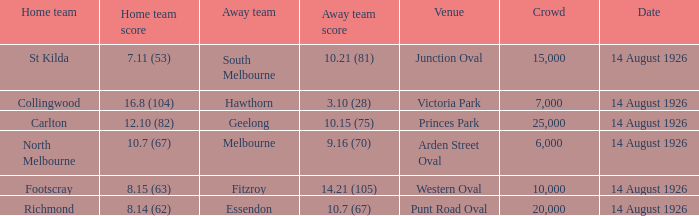What was the size of the largest crowd that Essendon played in front of as the away team? 20000.0. Can you give me this table as a dict? {'header': ['Home team', 'Home team score', 'Away team', 'Away team score', 'Venue', 'Crowd', 'Date'], 'rows': [['St Kilda', '7.11 (53)', 'South Melbourne', '10.21 (81)', 'Junction Oval', '15,000', '14 August 1926'], ['Collingwood', '16.8 (104)', 'Hawthorn', '3.10 (28)', 'Victoria Park', '7,000', '14 August 1926'], ['Carlton', '12.10 (82)', 'Geelong', '10.15 (75)', 'Princes Park', '25,000', '14 August 1926'], ['North Melbourne', '10.7 (67)', 'Melbourne', '9.16 (70)', 'Arden Street Oval', '6,000', '14 August 1926'], ['Footscray', '8.15 (63)', 'Fitzroy', '14.21 (105)', 'Western Oval', '10,000', '14 August 1926'], ['Richmond', '8.14 (62)', 'Essendon', '10.7 (67)', 'Punt Road Oval', '20,000', '14 August 1926']]} 